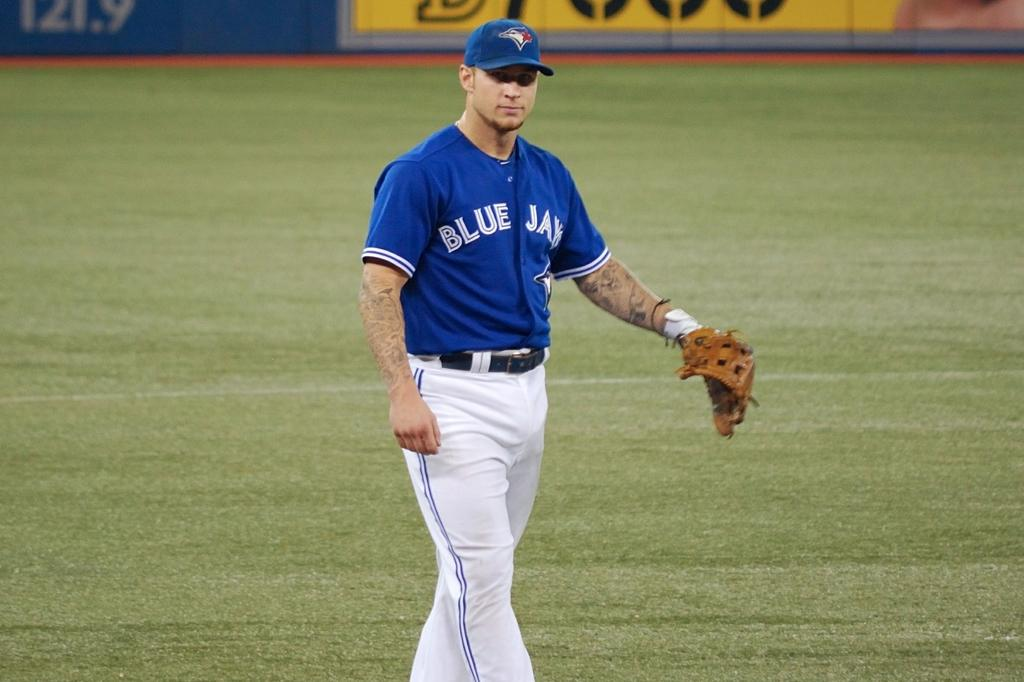Provide a one-sentence caption for the provided image. Baseball player in the outfield who plays for the Toronto Blue Jays. 